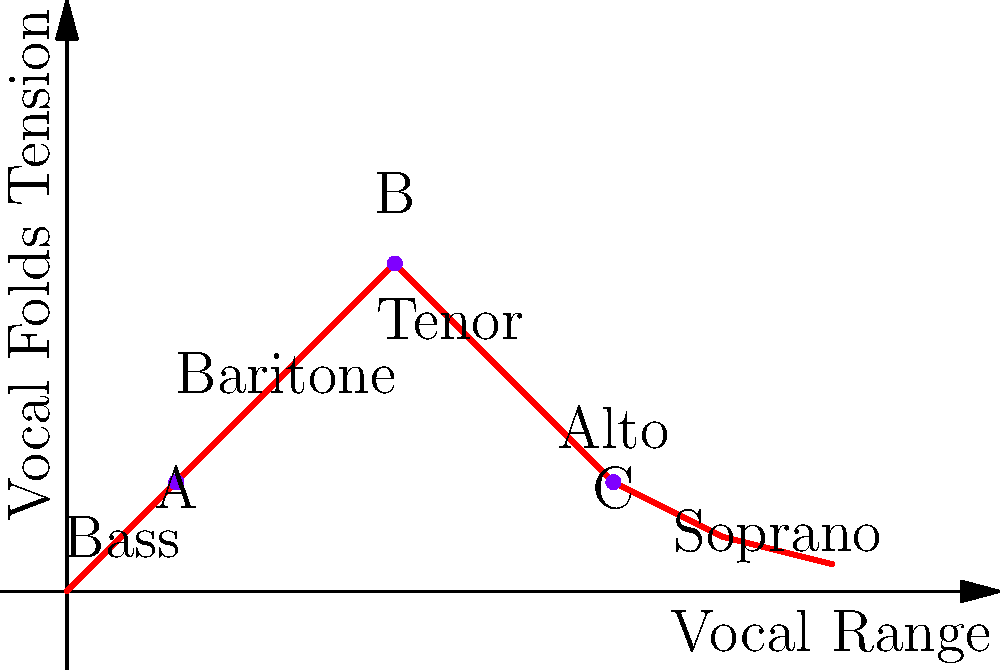The diagram illustrates the relationship between vocal range and vocal folds tension. Points A, B, and C represent different singing positions. As a versatile vocalist, which point would likely correspond to your highest chest voice note, and why? To answer this question, let's analyze the diagram and the characteristics of a versatile vocalist:

1. The x-axis represents the vocal range, from low (left) to high (right).
2. The y-axis represents vocal folds tension, which generally increases for higher notes.
3. The curve shows the relationship between range and tension for different voice types.

4. Point A: Located in the bass/baritone range with low tension.
5. Point B: Located in the tenor range with high tension.
6. Point C: Located in the alto range with moderate tension.

7. As a versatile vocalist who transitions smoothly between genres, you likely have a wide range.
8. The highest chest voice note typically occurs at the point of maximum vocal folds tension before transitioning to head voice or falsetto.
9. Among the given points, B has the highest tension and is in the tenor range, which is typically the highest male chest voice range.

Therefore, point B would most likely correspond to your highest chest voice note as a versatile vocalist. It represents the point of maximum tension in the upper range of the male voice, before transitioning to head voice or falsetto.
Answer: Point B 